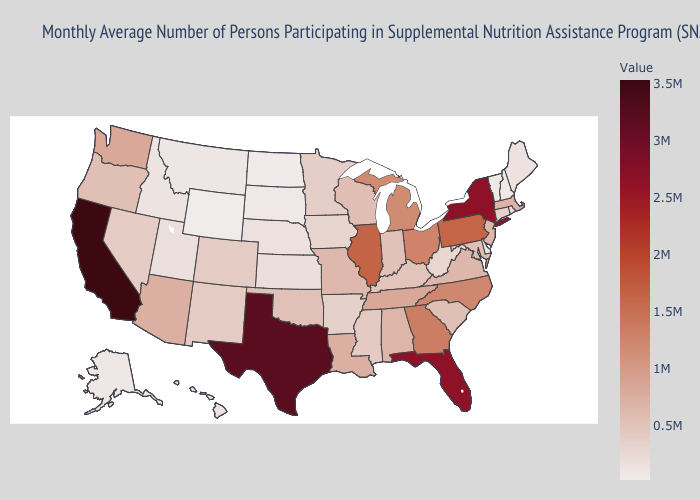Does Montana have the lowest value in the USA?
Give a very brief answer. No. Which states have the lowest value in the South?
Quick response, please. Delaware. Does California have a higher value than Kansas?
Answer briefly. Yes. Among the states that border Delaware , which have the lowest value?
Quick response, please. Maryland. Does Minnesota have the lowest value in the MidWest?
Concise answer only. No. Which states have the lowest value in the South?
Write a very short answer. Delaware. Which states hav the highest value in the South?
Give a very brief answer. Texas. Is the legend a continuous bar?
Write a very short answer. Yes. 